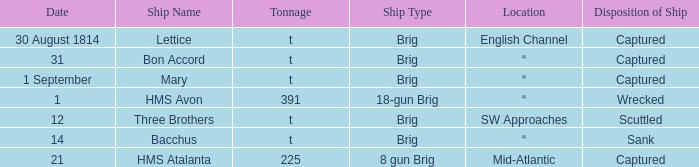Where was the ship when the ship had captured as the disposition of ship and was carrying 225 tonnage? Mid-Atlantic. 